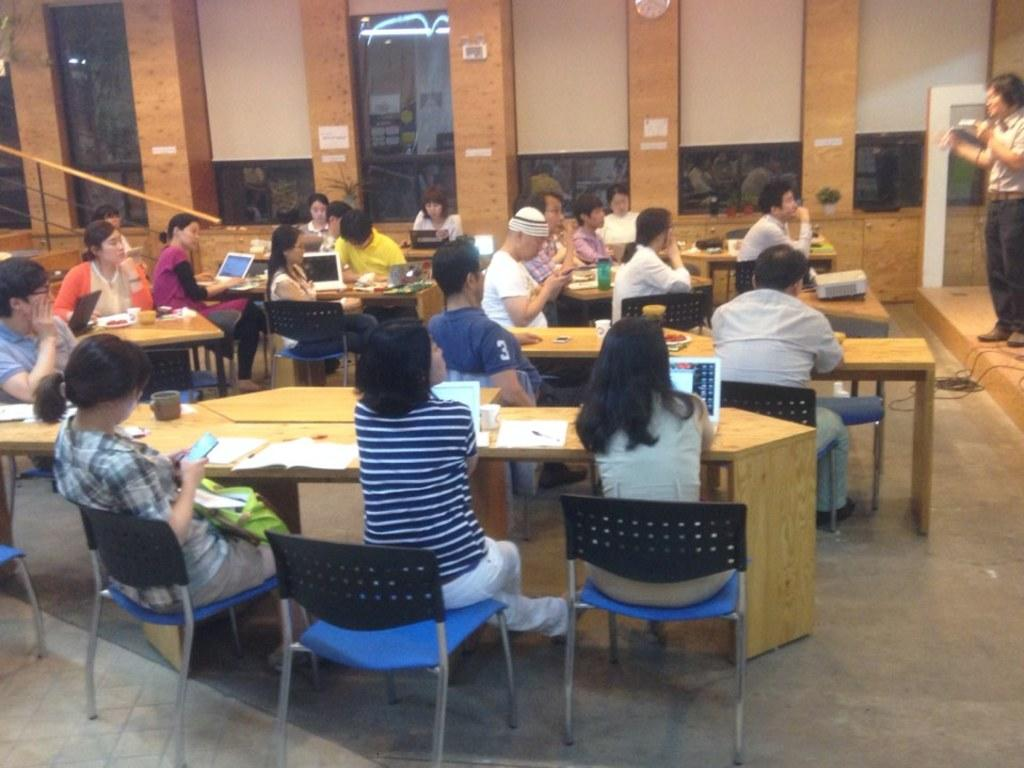What are the people in the image doing? There is a group of people sitting on chairs. What objects can be seen on the table in the image? There is a book and a laptop on the table. Is there anyone standing in the image? Yes, there is a man standing. Where is the crib located in the image? There is no crib present in the image. What type of sofa can be seen in the image? There is no sofa present in the image. 